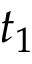<formula> <loc_0><loc_0><loc_500><loc_500>t _ { 1 }</formula> 